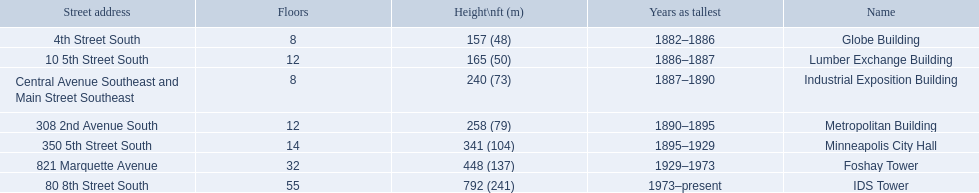Which buildings have the same number of floors as another building? Globe Building, Lumber Exchange Building, Industrial Exposition Building, Metropolitan Building. Of those, which has the same as the lumber exchange building? Metropolitan Building. 